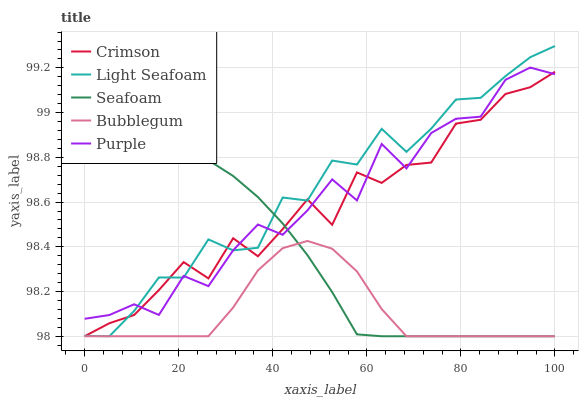Does Purple have the minimum area under the curve?
Answer yes or no. No. Does Purple have the maximum area under the curve?
Answer yes or no. No. Is Light Seafoam the smoothest?
Answer yes or no. No. Is Light Seafoam the roughest?
Answer yes or no. No. Does Purple have the lowest value?
Answer yes or no. No. Does Purple have the highest value?
Answer yes or no. No. Is Bubblegum less than Purple?
Answer yes or no. Yes. Is Purple greater than Bubblegum?
Answer yes or no. Yes. Does Bubblegum intersect Purple?
Answer yes or no. No. 